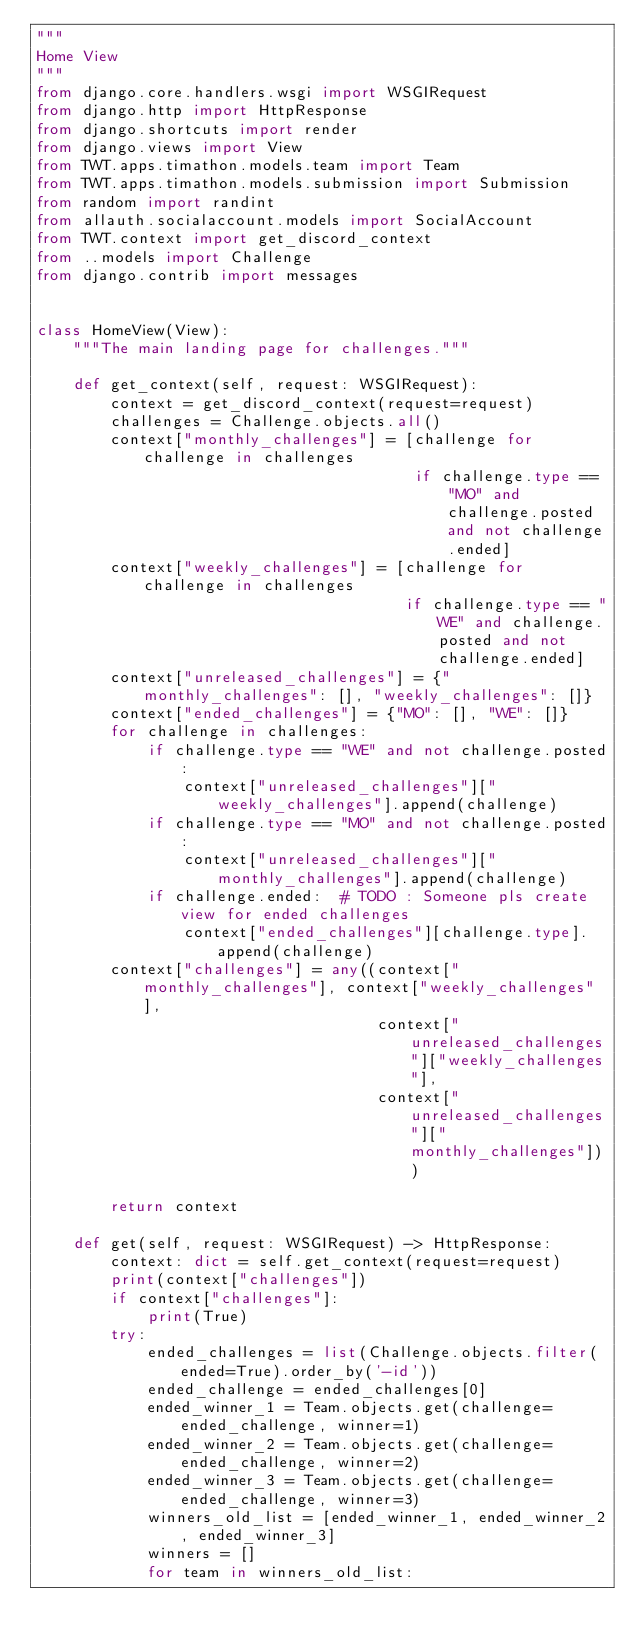Convert code to text. <code><loc_0><loc_0><loc_500><loc_500><_Python_>"""
Home View
"""
from django.core.handlers.wsgi import WSGIRequest
from django.http import HttpResponse
from django.shortcuts import render
from django.views import View
from TWT.apps.timathon.models.team import Team
from TWT.apps.timathon.models.submission import Submission
from random import randint
from allauth.socialaccount.models import SocialAccount
from TWT.context import get_discord_context
from ..models import Challenge
from django.contrib import messages


class HomeView(View):
    """The main landing page for challenges."""

    def get_context(self, request: WSGIRequest):
        context = get_discord_context(request=request)
        challenges = Challenge.objects.all()
        context["monthly_challenges"] = [challenge for challenge in challenges
                                         if challenge.type == "MO" and challenge.posted and not challenge.ended]
        context["weekly_challenges"] = [challenge for challenge in challenges
                                        if challenge.type == "WE" and challenge.posted and not challenge.ended]
        context["unreleased_challenges"] = {"monthly_challenges": [], "weekly_challenges": []}
        context["ended_challenges"] = {"MO": [], "WE": []}
        for challenge in challenges:
            if challenge.type == "WE" and not challenge.posted:
                context["unreleased_challenges"]["weekly_challenges"].append(challenge)
            if challenge.type == "MO" and not challenge.posted:
                context["unreleased_challenges"]["monthly_challenges"].append(challenge)
            if challenge.ended:  # TODO : Someone pls create view for ended challenges
                context["ended_challenges"][challenge.type].append(challenge)
        context["challenges"] = any((context["monthly_challenges"], context["weekly_challenges"],
                                     context["unreleased_challenges"]["weekly_challenges"],
                                     context["unreleased_challenges"]["monthly_challenges"]))

        return context

    def get(self, request: WSGIRequest) -> HttpResponse:
        context: dict = self.get_context(request=request)
        print(context["challenges"])
        if context["challenges"]:
            print(True)
        try:
            ended_challenges = list(Challenge.objects.filter(ended=True).order_by('-id'))
            ended_challenge = ended_challenges[0]
            ended_winner_1 = Team.objects.get(challenge=ended_challenge, winner=1)
            ended_winner_2 = Team.objects.get(challenge=ended_challenge, winner=2)
            ended_winner_3 = Team.objects.get(challenge=ended_challenge, winner=3)
            winners_old_list = [ended_winner_1, ended_winner_2, ended_winner_3]
            winners = []
            for team in winners_old_list:</code> 